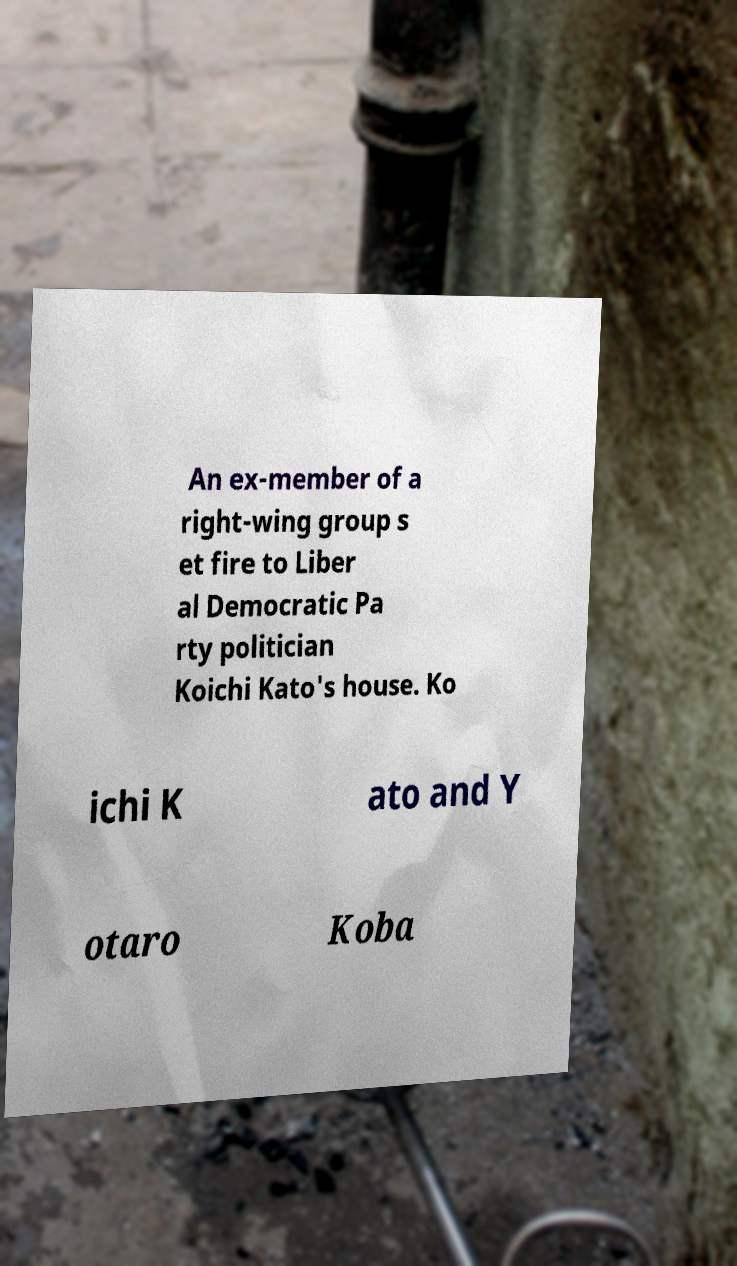For documentation purposes, I need the text within this image transcribed. Could you provide that? An ex-member of a right-wing group s et fire to Liber al Democratic Pa rty politician Koichi Kato's house. Ko ichi K ato and Y otaro Koba 